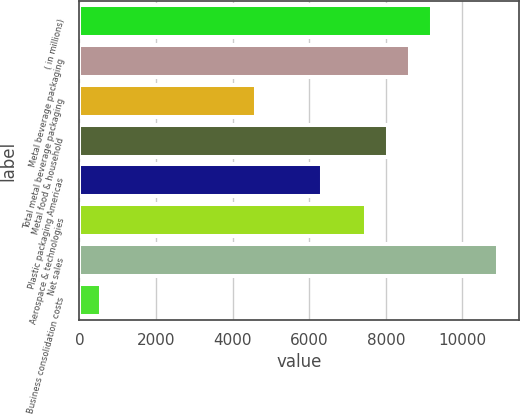Convert chart to OTSL. <chart><loc_0><loc_0><loc_500><loc_500><bar_chart><fcel>( in millions)<fcel>Metal beverage packaging<fcel>Total metal beverage packaging<fcel>Metal food & household<fcel>Plastic packaging Americas<fcel>Aerospace & technologies<fcel>Net sales<fcel>Business consolidation costs<nl><fcel>9201.44<fcel>8626.4<fcel>4601.12<fcel>8051.36<fcel>6326.24<fcel>7476.32<fcel>10926.6<fcel>575.84<nl></chart> 